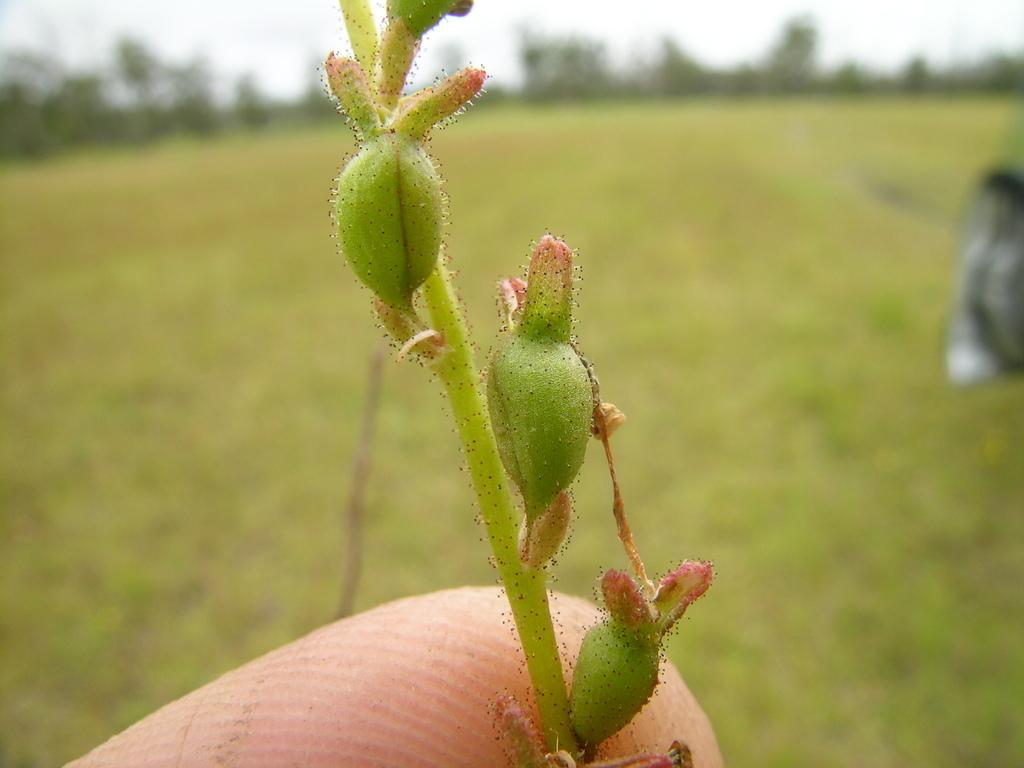What is the main subject of the image? The main subject of the image is a plant stem. Can you describe any other elements in the image? Yes, a person's finger is visible in the image, as well as grass at the bottom and trees in the background. What type of ray is swimming in the background of the image? There is no ray present in the image; it features a plant stem, a person's finger, grass, and trees. 